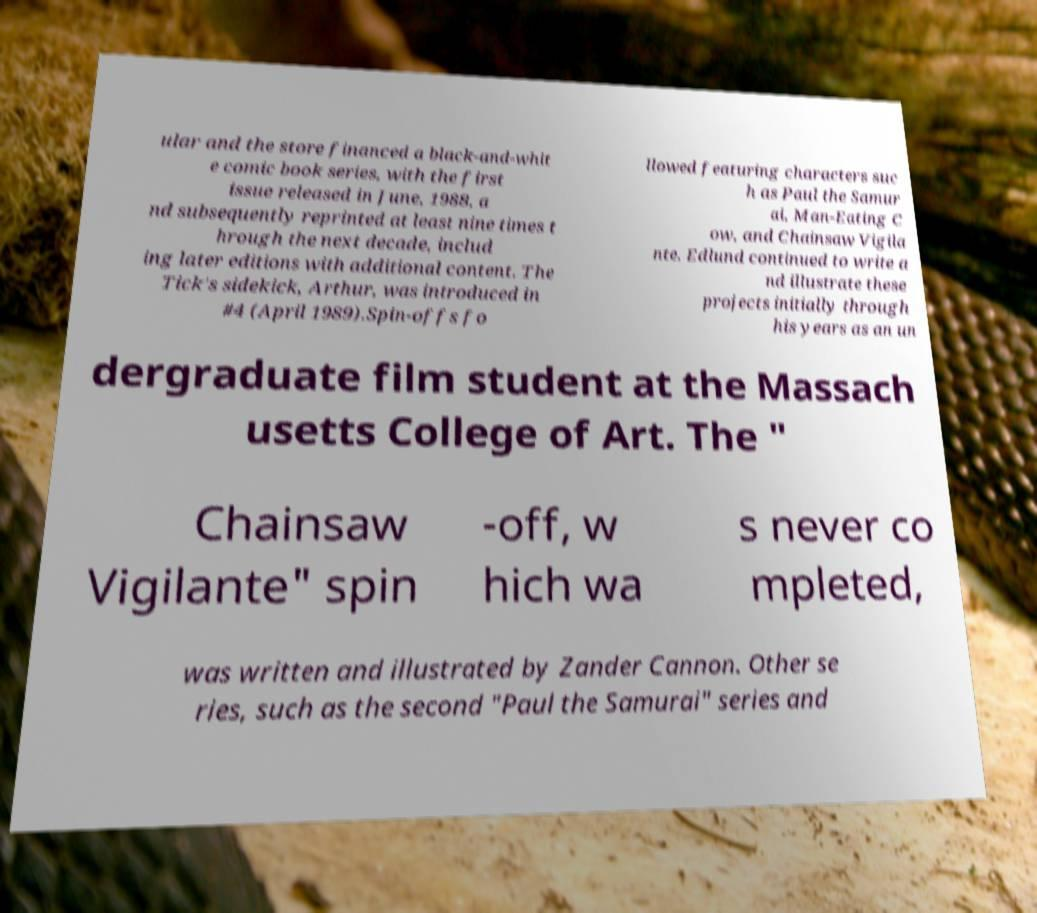Please read and relay the text visible in this image. What does it say? ular and the store financed a black-and-whit e comic book series, with the first issue released in June, 1988, a nd subsequently reprinted at least nine times t hrough the next decade, includ ing later editions with additional content. The Tick's sidekick, Arthur, was introduced in #4 (April 1989).Spin-offs fo llowed featuring characters suc h as Paul the Samur ai, Man-Eating C ow, and Chainsaw Vigila nte. Edlund continued to write a nd illustrate these projects initially through his years as an un dergraduate film student at the Massach usetts College of Art. The " Chainsaw Vigilante" spin -off, w hich wa s never co mpleted, was written and illustrated by Zander Cannon. Other se ries, such as the second "Paul the Samurai" series and 